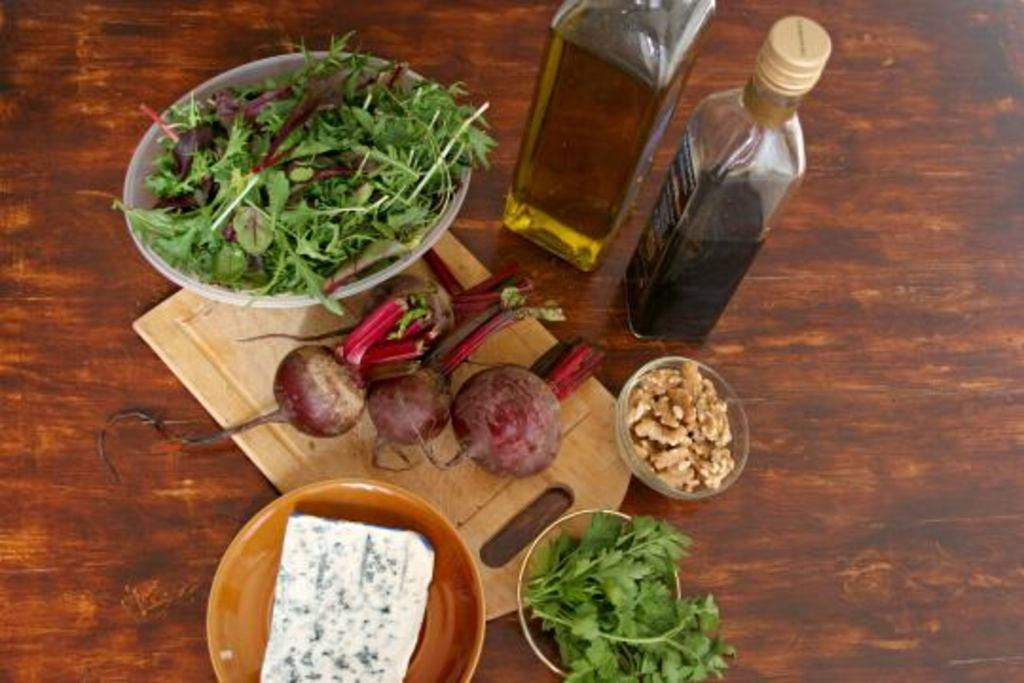What type of food items are present in the image? There are vegetables in the image. What can be seen besides the vegetables? There are oil bottles in the image. What is the color of the table in the image? The table in the image has a chocolate color. What grade does the truck receive in the image? There is no truck present in the image, so it cannot receive a grade. 